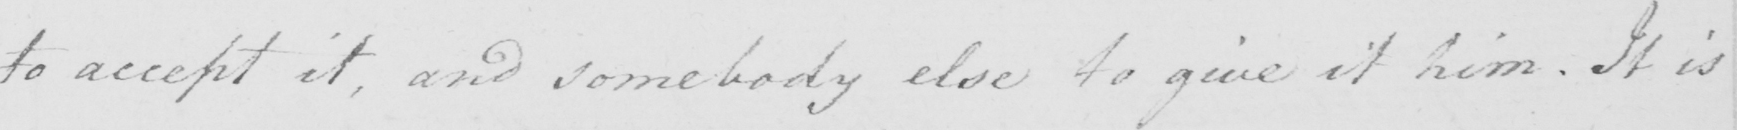Please transcribe the handwritten text in this image. to accept it , and somebody else to give it him . It is 